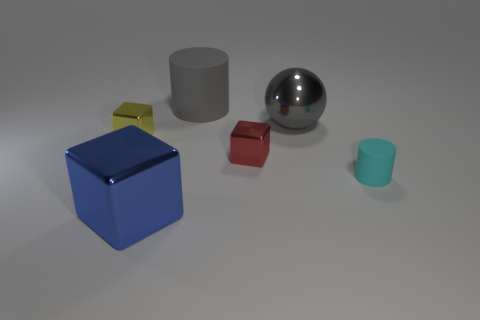Is there a matte cylinder that has the same color as the large ball?
Ensure brevity in your answer.  Yes. Does the blue thing have the same material as the red thing?
Provide a short and direct response. Yes. There is a red metal block; how many small cylinders are on the right side of it?
Your answer should be very brief. 1. What is the material of the object that is in front of the red cube and behind the big cube?
Keep it short and to the point. Rubber. How many yellow metallic spheres have the same size as the gray metallic thing?
Offer a very short reply. 0. The big metal thing that is behind the tiny thing right of the red block is what color?
Provide a succinct answer. Gray. Is there a metal cylinder?
Make the answer very short. No. Is the shape of the large blue object the same as the red metallic object?
Give a very brief answer. Yes. There is a big gray thing that is to the right of the gray matte thing; what number of small blocks are in front of it?
Ensure brevity in your answer.  2. How many big metal objects are behind the tiny cyan thing and in front of the tiny cyan matte cylinder?
Make the answer very short. 0. 